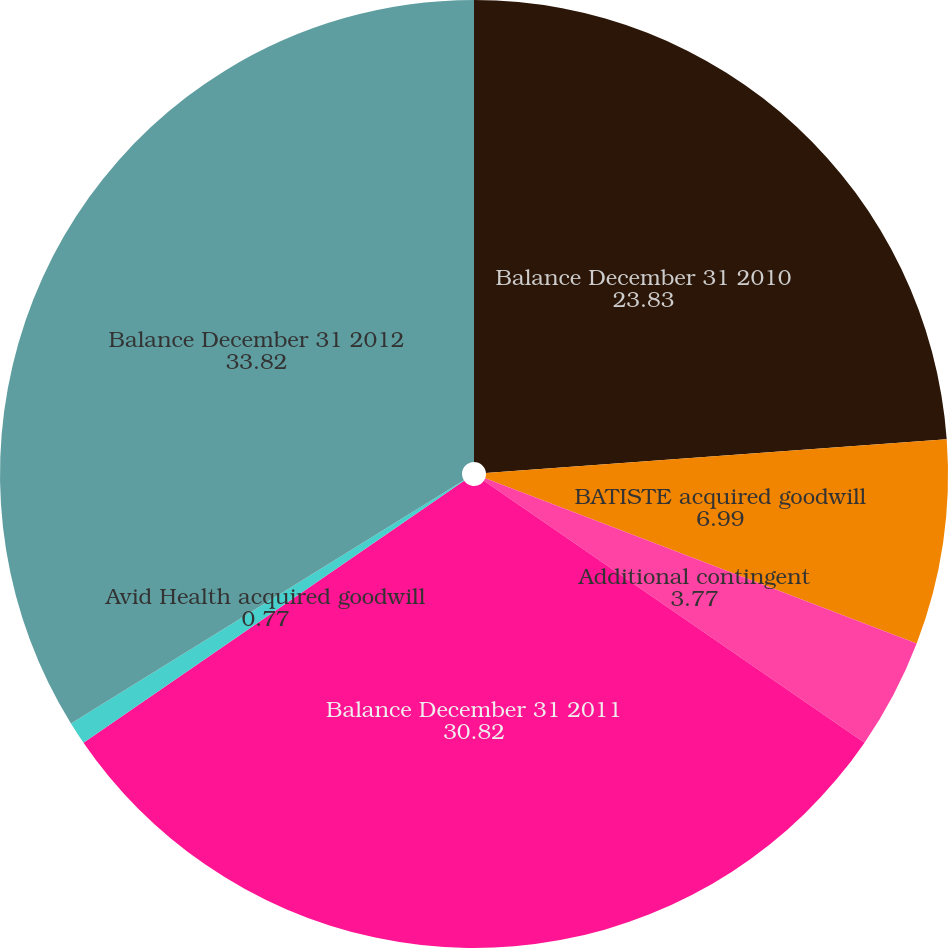<chart> <loc_0><loc_0><loc_500><loc_500><pie_chart><fcel>Balance December 31 2010<fcel>BATISTE acquired goodwill<fcel>Additional contingent<fcel>Balance December 31 2011<fcel>Avid Health acquired goodwill<fcel>Balance December 31 2012<nl><fcel>23.83%<fcel>6.99%<fcel>3.77%<fcel>30.82%<fcel>0.77%<fcel>33.82%<nl></chart> 